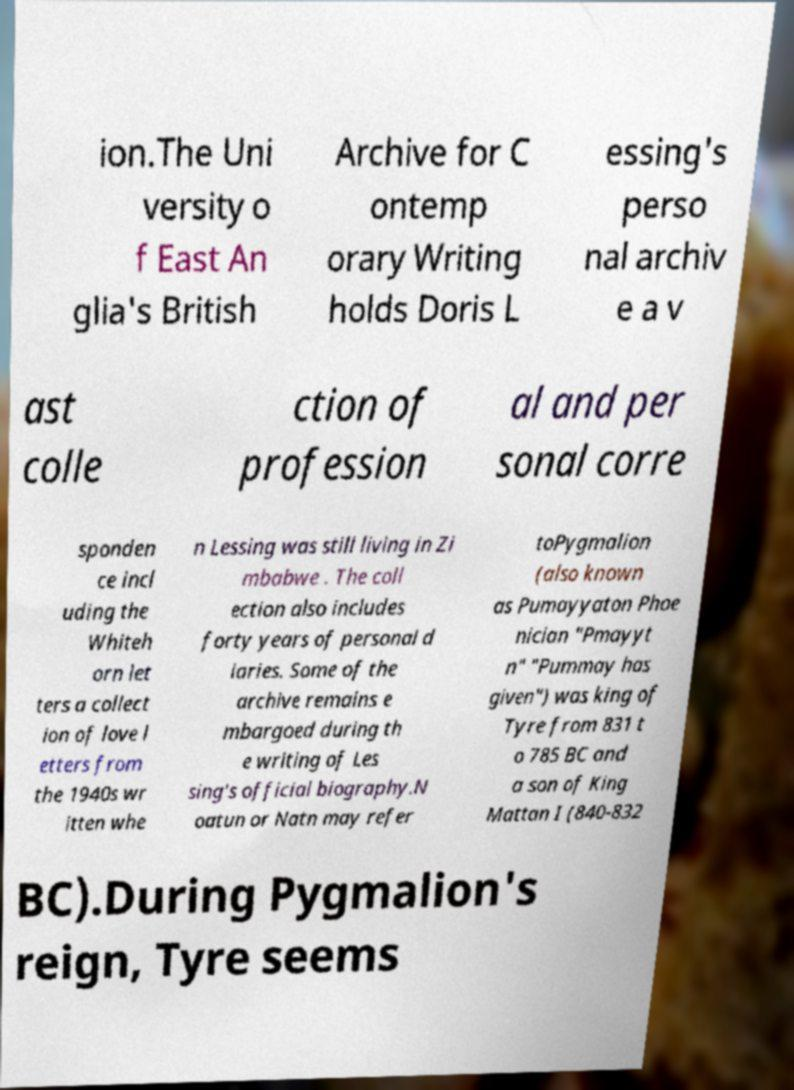I need the written content from this picture converted into text. Can you do that? ion.The Uni versity o f East An glia's British Archive for C ontemp orary Writing holds Doris L essing's perso nal archiv e a v ast colle ction of profession al and per sonal corre sponden ce incl uding the Whiteh orn let ters a collect ion of love l etters from the 1940s wr itten whe n Lessing was still living in Zi mbabwe . The coll ection also includes forty years of personal d iaries. Some of the archive remains e mbargoed during th e writing of Les sing's official biography.N oatun or Natn may refer toPygmalion (also known as Pumayyaton Phoe nician "Pmayyt n" "Pummay has given") was king of Tyre from 831 t o 785 BC and a son of King Mattan I (840-832 BC).During Pygmalion's reign, Tyre seems 